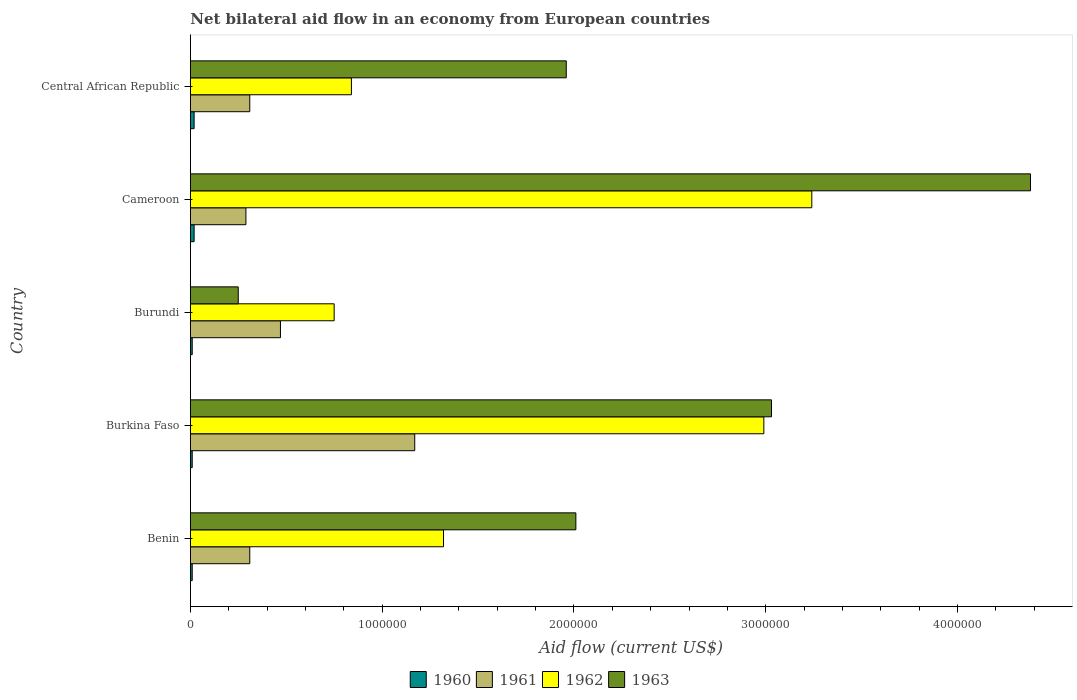Are the number of bars per tick equal to the number of legend labels?
Give a very brief answer. Yes. Are the number of bars on each tick of the Y-axis equal?
Offer a terse response. Yes. What is the label of the 4th group of bars from the top?
Your answer should be compact. Burkina Faso. Across all countries, what is the maximum net bilateral aid flow in 1961?
Offer a terse response. 1.17e+06. Across all countries, what is the minimum net bilateral aid flow in 1960?
Provide a short and direct response. 10000. In which country was the net bilateral aid flow in 1961 maximum?
Your answer should be compact. Burkina Faso. In which country was the net bilateral aid flow in 1963 minimum?
Provide a short and direct response. Burundi. What is the total net bilateral aid flow in 1960 in the graph?
Your response must be concise. 7.00e+04. What is the difference between the net bilateral aid flow in 1962 in Benin and that in Burundi?
Offer a very short reply. 5.70e+05. What is the difference between the net bilateral aid flow in 1963 in Burkina Faso and the net bilateral aid flow in 1960 in Central African Republic?
Provide a short and direct response. 3.01e+06. What is the average net bilateral aid flow in 1962 per country?
Ensure brevity in your answer.  1.83e+06. What is the difference between the net bilateral aid flow in 1961 and net bilateral aid flow in 1962 in Burundi?
Your response must be concise. -2.80e+05. In how many countries, is the net bilateral aid flow in 1963 greater than 2200000 US$?
Offer a very short reply. 2. What is the ratio of the net bilateral aid flow in 1963 in Benin to that in Burkina Faso?
Your answer should be compact. 0.66. Is the net bilateral aid flow in 1961 in Burkina Faso less than that in Burundi?
Your answer should be very brief. No. Is the difference between the net bilateral aid flow in 1961 in Burundi and Cameroon greater than the difference between the net bilateral aid flow in 1962 in Burundi and Cameroon?
Offer a terse response. Yes. What is the difference between the highest and the lowest net bilateral aid flow in 1962?
Keep it short and to the point. 2.49e+06. In how many countries, is the net bilateral aid flow in 1963 greater than the average net bilateral aid flow in 1963 taken over all countries?
Your answer should be very brief. 2. Is the sum of the net bilateral aid flow in 1961 in Benin and Central African Republic greater than the maximum net bilateral aid flow in 1960 across all countries?
Your answer should be very brief. Yes. Is it the case that in every country, the sum of the net bilateral aid flow in 1963 and net bilateral aid flow in 1962 is greater than the sum of net bilateral aid flow in 1960 and net bilateral aid flow in 1961?
Offer a very short reply. No. What does the 1st bar from the top in Benin represents?
Your response must be concise. 1963. Is it the case that in every country, the sum of the net bilateral aid flow in 1963 and net bilateral aid flow in 1962 is greater than the net bilateral aid flow in 1960?
Keep it short and to the point. Yes. Are all the bars in the graph horizontal?
Make the answer very short. Yes. How many countries are there in the graph?
Provide a succinct answer. 5. Are the values on the major ticks of X-axis written in scientific E-notation?
Make the answer very short. No. Does the graph contain any zero values?
Your response must be concise. No. Does the graph contain grids?
Keep it short and to the point. No. How are the legend labels stacked?
Ensure brevity in your answer.  Horizontal. What is the title of the graph?
Your answer should be very brief. Net bilateral aid flow in an economy from European countries. Does "2006" appear as one of the legend labels in the graph?
Provide a succinct answer. No. What is the label or title of the Y-axis?
Your answer should be compact. Country. What is the Aid flow (current US$) of 1960 in Benin?
Give a very brief answer. 10000. What is the Aid flow (current US$) of 1962 in Benin?
Give a very brief answer. 1.32e+06. What is the Aid flow (current US$) in 1963 in Benin?
Offer a very short reply. 2.01e+06. What is the Aid flow (current US$) of 1961 in Burkina Faso?
Provide a short and direct response. 1.17e+06. What is the Aid flow (current US$) in 1962 in Burkina Faso?
Your response must be concise. 2.99e+06. What is the Aid flow (current US$) of 1963 in Burkina Faso?
Your answer should be compact. 3.03e+06. What is the Aid flow (current US$) in 1960 in Burundi?
Offer a very short reply. 10000. What is the Aid flow (current US$) in 1961 in Burundi?
Your answer should be compact. 4.70e+05. What is the Aid flow (current US$) of 1962 in Burundi?
Ensure brevity in your answer.  7.50e+05. What is the Aid flow (current US$) of 1962 in Cameroon?
Your response must be concise. 3.24e+06. What is the Aid flow (current US$) in 1963 in Cameroon?
Keep it short and to the point. 4.38e+06. What is the Aid flow (current US$) of 1962 in Central African Republic?
Offer a terse response. 8.40e+05. What is the Aid flow (current US$) of 1963 in Central African Republic?
Ensure brevity in your answer.  1.96e+06. Across all countries, what is the maximum Aid flow (current US$) in 1960?
Your response must be concise. 2.00e+04. Across all countries, what is the maximum Aid flow (current US$) in 1961?
Your answer should be very brief. 1.17e+06. Across all countries, what is the maximum Aid flow (current US$) of 1962?
Give a very brief answer. 3.24e+06. Across all countries, what is the maximum Aid flow (current US$) of 1963?
Make the answer very short. 4.38e+06. Across all countries, what is the minimum Aid flow (current US$) in 1960?
Your answer should be compact. 10000. Across all countries, what is the minimum Aid flow (current US$) of 1961?
Ensure brevity in your answer.  2.90e+05. Across all countries, what is the minimum Aid flow (current US$) in 1962?
Provide a short and direct response. 7.50e+05. Across all countries, what is the minimum Aid flow (current US$) in 1963?
Your answer should be compact. 2.50e+05. What is the total Aid flow (current US$) of 1960 in the graph?
Offer a terse response. 7.00e+04. What is the total Aid flow (current US$) of 1961 in the graph?
Your response must be concise. 2.55e+06. What is the total Aid flow (current US$) of 1962 in the graph?
Offer a very short reply. 9.14e+06. What is the total Aid flow (current US$) of 1963 in the graph?
Provide a short and direct response. 1.16e+07. What is the difference between the Aid flow (current US$) of 1960 in Benin and that in Burkina Faso?
Your answer should be very brief. 0. What is the difference between the Aid flow (current US$) in 1961 in Benin and that in Burkina Faso?
Offer a terse response. -8.60e+05. What is the difference between the Aid flow (current US$) of 1962 in Benin and that in Burkina Faso?
Your response must be concise. -1.67e+06. What is the difference between the Aid flow (current US$) of 1963 in Benin and that in Burkina Faso?
Keep it short and to the point. -1.02e+06. What is the difference between the Aid flow (current US$) of 1961 in Benin and that in Burundi?
Keep it short and to the point. -1.60e+05. What is the difference between the Aid flow (current US$) of 1962 in Benin and that in Burundi?
Keep it short and to the point. 5.70e+05. What is the difference between the Aid flow (current US$) in 1963 in Benin and that in Burundi?
Ensure brevity in your answer.  1.76e+06. What is the difference between the Aid flow (current US$) of 1960 in Benin and that in Cameroon?
Offer a terse response. -10000. What is the difference between the Aid flow (current US$) of 1962 in Benin and that in Cameroon?
Offer a very short reply. -1.92e+06. What is the difference between the Aid flow (current US$) of 1963 in Benin and that in Cameroon?
Offer a very short reply. -2.37e+06. What is the difference between the Aid flow (current US$) of 1960 in Benin and that in Central African Republic?
Make the answer very short. -10000. What is the difference between the Aid flow (current US$) in 1963 in Benin and that in Central African Republic?
Your answer should be very brief. 5.00e+04. What is the difference between the Aid flow (current US$) of 1962 in Burkina Faso and that in Burundi?
Provide a short and direct response. 2.24e+06. What is the difference between the Aid flow (current US$) of 1963 in Burkina Faso and that in Burundi?
Give a very brief answer. 2.78e+06. What is the difference between the Aid flow (current US$) in 1960 in Burkina Faso and that in Cameroon?
Ensure brevity in your answer.  -10000. What is the difference between the Aid flow (current US$) in 1961 in Burkina Faso and that in Cameroon?
Your answer should be very brief. 8.80e+05. What is the difference between the Aid flow (current US$) of 1963 in Burkina Faso and that in Cameroon?
Offer a terse response. -1.35e+06. What is the difference between the Aid flow (current US$) of 1961 in Burkina Faso and that in Central African Republic?
Provide a short and direct response. 8.60e+05. What is the difference between the Aid flow (current US$) in 1962 in Burkina Faso and that in Central African Republic?
Your response must be concise. 2.15e+06. What is the difference between the Aid flow (current US$) in 1963 in Burkina Faso and that in Central African Republic?
Provide a succinct answer. 1.07e+06. What is the difference between the Aid flow (current US$) of 1961 in Burundi and that in Cameroon?
Your answer should be very brief. 1.80e+05. What is the difference between the Aid flow (current US$) in 1962 in Burundi and that in Cameroon?
Your answer should be compact. -2.49e+06. What is the difference between the Aid flow (current US$) of 1963 in Burundi and that in Cameroon?
Your response must be concise. -4.13e+06. What is the difference between the Aid flow (current US$) of 1960 in Burundi and that in Central African Republic?
Your answer should be compact. -10000. What is the difference between the Aid flow (current US$) of 1962 in Burundi and that in Central African Republic?
Give a very brief answer. -9.00e+04. What is the difference between the Aid flow (current US$) of 1963 in Burundi and that in Central African Republic?
Provide a short and direct response. -1.71e+06. What is the difference between the Aid flow (current US$) in 1960 in Cameroon and that in Central African Republic?
Offer a very short reply. 0. What is the difference between the Aid flow (current US$) in 1961 in Cameroon and that in Central African Republic?
Your answer should be compact. -2.00e+04. What is the difference between the Aid flow (current US$) of 1962 in Cameroon and that in Central African Republic?
Your answer should be compact. 2.40e+06. What is the difference between the Aid flow (current US$) in 1963 in Cameroon and that in Central African Republic?
Offer a terse response. 2.42e+06. What is the difference between the Aid flow (current US$) in 1960 in Benin and the Aid flow (current US$) in 1961 in Burkina Faso?
Make the answer very short. -1.16e+06. What is the difference between the Aid flow (current US$) in 1960 in Benin and the Aid flow (current US$) in 1962 in Burkina Faso?
Make the answer very short. -2.98e+06. What is the difference between the Aid flow (current US$) in 1960 in Benin and the Aid flow (current US$) in 1963 in Burkina Faso?
Your answer should be very brief. -3.02e+06. What is the difference between the Aid flow (current US$) in 1961 in Benin and the Aid flow (current US$) in 1962 in Burkina Faso?
Ensure brevity in your answer.  -2.68e+06. What is the difference between the Aid flow (current US$) in 1961 in Benin and the Aid flow (current US$) in 1963 in Burkina Faso?
Offer a terse response. -2.72e+06. What is the difference between the Aid flow (current US$) of 1962 in Benin and the Aid flow (current US$) of 1963 in Burkina Faso?
Your answer should be very brief. -1.71e+06. What is the difference between the Aid flow (current US$) of 1960 in Benin and the Aid flow (current US$) of 1961 in Burundi?
Your response must be concise. -4.60e+05. What is the difference between the Aid flow (current US$) in 1960 in Benin and the Aid flow (current US$) in 1962 in Burundi?
Make the answer very short. -7.40e+05. What is the difference between the Aid flow (current US$) of 1960 in Benin and the Aid flow (current US$) of 1963 in Burundi?
Keep it short and to the point. -2.40e+05. What is the difference between the Aid flow (current US$) of 1961 in Benin and the Aid flow (current US$) of 1962 in Burundi?
Make the answer very short. -4.40e+05. What is the difference between the Aid flow (current US$) of 1962 in Benin and the Aid flow (current US$) of 1963 in Burundi?
Your answer should be very brief. 1.07e+06. What is the difference between the Aid flow (current US$) of 1960 in Benin and the Aid flow (current US$) of 1961 in Cameroon?
Your response must be concise. -2.80e+05. What is the difference between the Aid flow (current US$) of 1960 in Benin and the Aid flow (current US$) of 1962 in Cameroon?
Your response must be concise. -3.23e+06. What is the difference between the Aid flow (current US$) of 1960 in Benin and the Aid flow (current US$) of 1963 in Cameroon?
Offer a terse response. -4.37e+06. What is the difference between the Aid flow (current US$) in 1961 in Benin and the Aid flow (current US$) in 1962 in Cameroon?
Provide a succinct answer. -2.93e+06. What is the difference between the Aid flow (current US$) in 1961 in Benin and the Aid flow (current US$) in 1963 in Cameroon?
Your answer should be very brief. -4.07e+06. What is the difference between the Aid flow (current US$) of 1962 in Benin and the Aid flow (current US$) of 1963 in Cameroon?
Offer a terse response. -3.06e+06. What is the difference between the Aid flow (current US$) of 1960 in Benin and the Aid flow (current US$) of 1961 in Central African Republic?
Offer a very short reply. -3.00e+05. What is the difference between the Aid flow (current US$) in 1960 in Benin and the Aid flow (current US$) in 1962 in Central African Republic?
Give a very brief answer. -8.30e+05. What is the difference between the Aid flow (current US$) in 1960 in Benin and the Aid flow (current US$) in 1963 in Central African Republic?
Ensure brevity in your answer.  -1.95e+06. What is the difference between the Aid flow (current US$) in 1961 in Benin and the Aid flow (current US$) in 1962 in Central African Republic?
Offer a very short reply. -5.30e+05. What is the difference between the Aid flow (current US$) of 1961 in Benin and the Aid flow (current US$) of 1963 in Central African Republic?
Give a very brief answer. -1.65e+06. What is the difference between the Aid flow (current US$) of 1962 in Benin and the Aid flow (current US$) of 1963 in Central African Republic?
Provide a succinct answer. -6.40e+05. What is the difference between the Aid flow (current US$) of 1960 in Burkina Faso and the Aid flow (current US$) of 1961 in Burundi?
Your response must be concise. -4.60e+05. What is the difference between the Aid flow (current US$) of 1960 in Burkina Faso and the Aid flow (current US$) of 1962 in Burundi?
Ensure brevity in your answer.  -7.40e+05. What is the difference between the Aid flow (current US$) of 1960 in Burkina Faso and the Aid flow (current US$) of 1963 in Burundi?
Provide a succinct answer. -2.40e+05. What is the difference between the Aid flow (current US$) in 1961 in Burkina Faso and the Aid flow (current US$) in 1962 in Burundi?
Your answer should be very brief. 4.20e+05. What is the difference between the Aid flow (current US$) in 1961 in Burkina Faso and the Aid flow (current US$) in 1963 in Burundi?
Make the answer very short. 9.20e+05. What is the difference between the Aid flow (current US$) in 1962 in Burkina Faso and the Aid flow (current US$) in 1963 in Burundi?
Provide a short and direct response. 2.74e+06. What is the difference between the Aid flow (current US$) of 1960 in Burkina Faso and the Aid flow (current US$) of 1961 in Cameroon?
Your answer should be very brief. -2.80e+05. What is the difference between the Aid flow (current US$) of 1960 in Burkina Faso and the Aid flow (current US$) of 1962 in Cameroon?
Give a very brief answer. -3.23e+06. What is the difference between the Aid flow (current US$) of 1960 in Burkina Faso and the Aid flow (current US$) of 1963 in Cameroon?
Ensure brevity in your answer.  -4.37e+06. What is the difference between the Aid flow (current US$) of 1961 in Burkina Faso and the Aid flow (current US$) of 1962 in Cameroon?
Make the answer very short. -2.07e+06. What is the difference between the Aid flow (current US$) in 1961 in Burkina Faso and the Aid flow (current US$) in 1963 in Cameroon?
Offer a terse response. -3.21e+06. What is the difference between the Aid flow (current US$) in 1962 in Burkina Faso and the Aid flow (current US$) in 1963 in Cameroon?
Offer a terse response. -1.39e+06. What is the difference between the Aid flow (current US$) in 1960 in Burkina Faso and the Aid flow (current US$) in 1962 in Central African Republic?
Your answer should be very brief. -8.30e+05. What is the difference between the Aid flow (current US$) of 1960 in Burkina Faso and the Aid flow (current US$) of 1963 in Central African Republic?
Give a very brief answer. -1.95e+06. What is the difference between the Aid flow (current US$) in 1961 in Burkina Faso and the Aid flow (current US$) in 1962 in Central African Republic?
Your answer should be very brief. 3.30e+05. What is the difference between the Aid flow (current US$) in 1961 in Burkina Faso and the Aid flow (current US$) in 1963 in Central African Republic?
Make the answer very short. -7.90e+05. What is the difference between the Aid flow (current US$) of 1962 in Burkina Faso and the Aid flow (current US$) of 1963 in Central African Republic?
Keep it short and to the point. 1.03e+06. What is the difference between the Aid flow (current US$) in 1960 in Burundi and the Aid flow (current US$) in 1961 in Cameroon?
Give a very brief answer. -2.80e+05. What is the difference between the Aid flow (current US$) in 1960 in Burundi and the Aid flow (current US$) in 1962 in Cameroon?
Your response must be concise. -3.23e+06. What is the difference between the Aid flow (current US$) of 1960 in Burundi and the Aid flow (current US$) of 1963 in Cameroon?
Your answer should be compact. -4.37e+06. What is the difference between the Aid flow (current US$) of 1961 in Burundi and the Aid flow (current US$) of 1962 in Cameroon?
Keep it short and to the point. -2.77e+06. What is the difference between the Aid flow (current US$) in 1961 in Burundi and the Aid flow (current US$) in 1963 in Cameroon?
Offer a very short reply. -3.91e+06. What is the difference between the Aid flow (current US$) of 1962 in Burundi and the Aid flow (current US$) of 1963 in Cameroon?
Provide a succinct answer. -3.63e+06. What is the difference between the Aid flow (current US$) of 1960 in Burundi and the Aid flow (current US$) of 1961 in Central African Republic?
Your answer should be very brief. -3.00e+05. What is the difference between the Aid flow (current US$) in 1960 in Burundi and the Aid flow (current US$) in 1962 in Central African Republic?
Provide a succinct answer. -8.30e+05. What is the difference between the Aid flow (current US$) in 1960 in Burundi and the Aid flow (current US$) in 1963 in Central African Republic?
Your response must be concise. -1.95e+06. What is the difference between the Aid flow (current US$) of 1961 in Burundi and the Aid flow (current US$) of 1962 in Central African Republic?
Ensure brevity in your answer.  -3.70e+05. What is the difference between the Aid flow (current US$) in 1961 in Burundi and the Aid flow (current US$) in 1963 in Central African Republic?
Make the answer very short. -1.49e+06. What is the difference between the Aid flow (current US$) in 1962 in Burundi and the Aid flow (current US$) in 1963 in Central African Republic?
Your response must be concise. -1.21e+06. What is the difference between the Aid flow (current US$) of 1960 in Cameroon and the Aid flow (current US$) of 1961 in Central African Republic?
Make the answer very short. -2.90e+05. What is the difference between the Aid flow (current US$) of 1960 in Cameroon and the Aid flow (current US$) of 1962 in Central African Republic?
Your response must be concise. -8.20e+05. What is the difference between the Aid flow (current US$) of 1960 in Cameroon and the Aid flow (current US$) of 1963 in Central African Republic?
Provide a short and direct response. -1.94e+06. What is the difference between the Aid flow (current US$) in 1961 in Cameroon and the Aid flow (current US$) in 1962 in Central African Republic?
Your response must be concise. -5.50e+05. What is the difference between the Aid flow (current US$) in 1961 in Cameroon and the Aid flow (current US$) in 1963 in Central African Republic?
Keep it short and to the point. -1.67e+06. What is the difference between the Aid flow (current US$) in 1962 in Cameroon and the Aid flow (current US$) in 1963 in Central African Republic?
Your response must be concise. 1.28e+06. What is the average Aid flow (current US$) in 1960 per country?
Keep it short and to the point. 1.40e+04. What is the average Aid flow (current US$) in 1961 per country?
Provide a succinct answer. 5.10e+05. What is the average Aid flow (current US$) of 1962 per country?
Keep it short and to the point. 1.83e+06. What is the average Aid flow (current US$) of 1963 per country?
Offer a very short reply. 2.33e+06. What is the difference between the Aid flow (current US$) of 1960 and Aid flow (current US$) of 1962 in Benin?
Provide a succinct answer. -1.31e+06. What is the difference between the Aid flow (current US$) in 1961 and Aid flow (current US$) in 1962 in Benin?
Keep it short and to the point. -1.01e+06. What is the difference between the Aid flow (current US$) in 1961 and Aid flow (current US$) in 1963 in Benin?
Ensure brevity in your answer.  -1.70e+06. What is the difference between the Aid flow (current US$) in 1962 and Aid flow (current US$) in 1963 in Benin?
Your answer should be very brief. -6.90e+05. What is the difference between the Aid flow (current US$) of 1960 and Aid flow (current US$) of 1961 in Burkina Faso?
Keep it short and to the point. -1.16e+06. What is the difference between the Aid flow (current US$) in 1960 and Aid flow (current US$) in 1962 in Burkina Faso?
Make the answer very short. -2.98e+06. What is the difference between the Aid flow (current US$) in 1960 and Aid flow (current US$) in 1963 in Burkina Faso?
Make the answer very short. -3.02e+06. What is the difference between the Aid flow (current US$) of 1961 and Aid flow (current US$) of 1962 in Burkina Faso?
Provide a succinct answer. -1.82e+06. What is the difference between the Aid flow (current US$) in 1961 and Aid flow (current US$) in 1963 in Burkina Faso?
Give a very brief answer. -1.86e+06. What is the difference between the Aid flow (current US$) in 1962 and Aid flow (current US$) in 1963 in Burkina Faso?
Your answer should be very brief. -4.00e+04. What is the difference between the Aid flow (current US$) in 1960 and Aid flow (current US$) in 1961 in Burundi?
Offer a very short reply. -4.60e+05. What is the difference between the Aid flow (current US$) of 1960 and Aid flow (current US$) of 1962 in Burundi?
Offer a very short reply. -7.40e+05. What is the difference between the Aid flow (current US$) in 1961 and Aid flow (current US$) in 1962 in Burundi?
Keep it short and to the point. -2.80e+05. What is the difference between the Aid flow (current US$) in 1961 and Aid flow (current US$) in 1963 in Burundi?
Keep it short and to the point. 2.20e+05. What is the difference between the Aid flow (current US$) of 1960 and Aid flow (current US$) of 1961 in Cameroon?
Ensure brevity in your answer.  -2.70e+05. What is the difference between the Aid flow (current US$) in 1960 and Aid flow (current US$) in 1962 in Cameroon?
Your answer should be compact. -3.22e+06. What is the difference between the Aid flow (current US$) in 1960 and Aid flow (current US$) in 1963 in Cameroon?
Keep it short and to the point. -4.36e+06. What is the difference between the Aid flow (current US$) of 1961 and Aid flow (current US$) of 1962 in Cameroon?
Your answer should be very brief. -2.95e+06. What is the difference between the Aid flow (current US$) in 1961 and Aid flow (current US$) in 1963 in Cameroon?
Give a very brief answer. -4.09e+06. What is the difference between the Aid flow (current US$) of 1962 and Aid flow (current US$) of 1963 in Cameroon?
Make the answer very short. -1.14e+06. What is the difference between the Aid flow (current US$) of 1960 and Aid flow (current US$) of 1962 in Central African Republic?
Your answer should be very brief. -8.20e+05. What is the difference between the Aid flow (current US$) in 1960 and Aid flow (current US$) in 1963 in Central African Republic?
Provide a short and direct response. -1.94e+06. What is the difference between the Aid flow (current US$) of 1961 and Aid flow (current US$) of 1962 in Central African Republic?
Your response must be concise. -5.30e+05. What is the difference between the Aid flow (current US$) of 1961 and Aid flow (current US$) of 1963 in Central African Republic?
Make the answer very short. -1.65e+06. What is the difference between the Aid flow (current US$) in 1962 and Aid flow (current US$) in 1963 in Central African Republic?
Provide a short and direct response. -1.12e+06. What is the ratio of the Aid flow (current US$) in 1961 in Benin to that in Burkina Faso?
Your answer should be very brief. 0.27. What is the ratio of the Aid flow (current US$) in 1962 in Benin to that in Burkina Faso?
Your response must be concise. 0.44. What is the ratio of the Aid flow (current US$) in 1963 in Benin to that in Burkina Faso?
Ensure brevity in your answer.  0.66. What is the ratio of the Aid flow (current US$) of 1960 in Benin to that in Burundi?
Keep it short and to the point. 1. What is the ratio of the Aid flow (current US$) in 1961 in Benin to that in Burundi?
Your answer should be very brief. 0.66. What is the ratio of the Aid flow (current US$) in 1962 in Benin to that in Burundi?
Keep it short and to the point. 1.76. What is the ratio of the Aid flow (current US$) in 1963 in Benin to that in Burundi?
Offer a very short reply. 8.04. What is the ratio of the Aid flow (current US$) in 1961 in Benin to that in Cameroon?
Provide a succinct answer. 1.07. What is the ratio of the Aid flow (current US$) in 1962 in Benin to that in Cameroon?
Offer a very short reply. 0.41. What is the ratio of the Aid flow (current US$) in 1963 in Benin to that in Cameroon?
Your response must be concise. 0.46. What is the ratio of the Aid flow (current US$) in 1960 in Benin to that in Central African Republic?
Your answer should be compact. 0.5. What is the ratio of the Aid flow (current US$) in 1961 in Benin to that in Central African Republic?
Your response must be concise. 1. What is the ratio of the Aid flow (current US$) in 1962 in Benin to that in Central African Republic?
Offer a very short reply. 1.57. What is the ratio of the Aid flow (current US$) of 1963 in Benin to that in Central African Republic?
Offer a terse response. 1.03. What is the ratio of the Aid flow (current US$) of 1960 in Burkina Faso to that in Burundi?
Your answer should be compact. 1. What is the ratio of the Aid flow (current US$) of 1961 in Burkina Faso to that in Burundi?
Offer a very short reply. 2.49. What is the ratio of the Aid flow (current US$) in 1962 in Burkina Faso to that in Burundi?
Ensure brevity in your answer.  3.99. What is the ratio of the Aid flow (current US$) in 1963 in Burkina Faso to that in Burundi?
Make the answer very short. 12.12. What is the ratio of the Aid flow (current US$) in 1961 in Burkina Faso to that in Cameroon?
Give a very brief answer. 4.03. What is the ratio of the Aid flow (current US$) of 1962 in Burkina Faso to that in Cameroon?
Give a very brief answer. 0.92. What is the ratio of the Aid flow (current US$) of 1963 in Burkina Faso to that in Cameroon?
Offer a very short reply. 0.69. What is the ratio of the Aid flow (current US$) in 1961 in Burkina Faso to that in Central African Republic?
Offer a very short reply. 3.77. What is the ratio of the Aid flow (current US$) in 1962 in Burkina Faso to that in Central African Republic?
Make the answer very short. 3.56. What is the ratio of the Aid flow (current US$) of 1963 in Burkina Faso to that in Central African Republic?
Offer a very short reply. 1.55. What is the ratio of the Aid flow (current US$) of 1960 in Burundi to that in Cameroon?
Make the answer very short. 0.5. What is the ratio of the Aid flow (current US$) of 1961 in Burundi to that in Cameroon?
Your answer should be compact. 1.62. What is the ratio of the Aid flow (current US$) of 1962 in Burundi to that in Cameroon?
Provide a succinct answer. 0.23. What is the ratio of the Aid flow (current US$) of 1963 in Burundi to that in Cameroon?
Your answer should be compact. 0.06. What is the ratio of the Aid flow (current US$) of 1961 in Burundi to that in Central African Republic?
Keep it short and to the point. 1.52. What is the ratio of the Aid flow (current US$) of 1962 in Burundi to that in Central African Republic?
Provide a short and direct response. 0.89. What is the ratio of the Aid flow (current US$) of 1963 in Burundi to that in Central African Republic?
Your response must be concise. 0.13. What is the ratio of the Aid flow (current US$) of 1960 in Cameroon to that in Central African Republic?
Offer a terse response. 1. What is the ratio of the Aid flow (current US$) of 1961 in Cameroon to that in Central African Republic?
Your answer should be compact. 0.94. What is the ratio of the Aid flow (current US$) in 1962 in Cameroon to that in Central African Republic?
Provide a succinct answer. 3.86. What is the ratio of the Aid flow (current US$) of 1963 in Cameroon to that in Central African Republic?
Keep it short and to the point. 2.23. What is the difference between the highest and the second highest Aid flow (current US$) in 1960?
Offer a very short reply. 0. What is the difference between the highest and the second highest Aid flow (current US$) in 1962?
Offer a very short reply. 2.50e+05. What is the difference between the highest and the second highest Aid flow (current US$) in 1963?
Provide a short and direct response. 1.35e+06. What is the difference between the highest and the lowest Aid flow (current US$) of 1961?
Ensure brevity in your answer.  8.80e+05. What is the difference between the highest and the lowest Aid flow (current US$) of 1962?
Make the answer very short. 2.49e+06. What is the difference between the highest and the lowest Aid flow (current US$) of 1963?
Keep it short and to the point. 4.13e+06. 